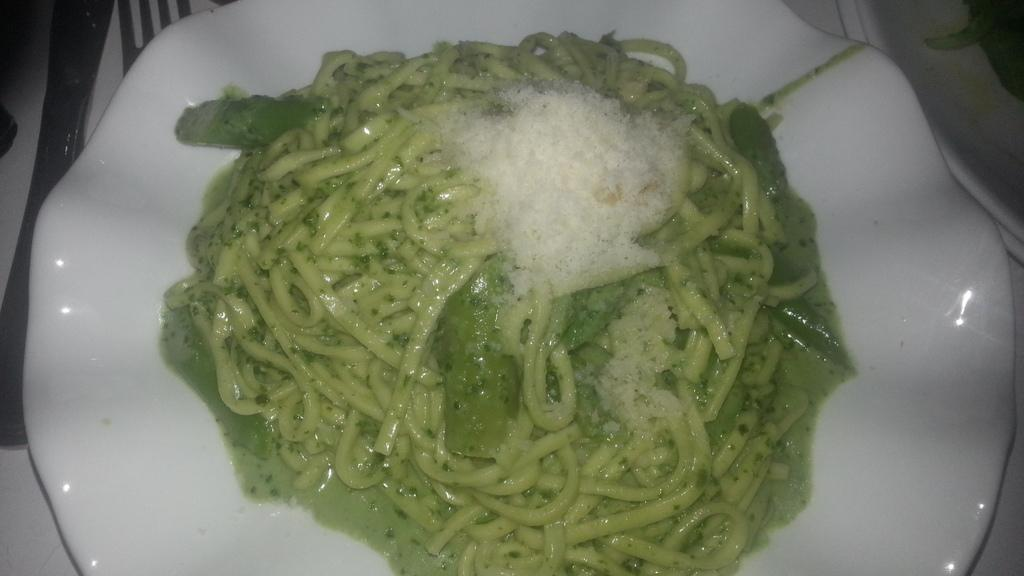What is the main subject of the image? There is a food item in the image. How is the food item presented in the image? The food item is on a plate. Where is the plate with the food item located? The plate is on a table. What type of polish is being applied to the lettuce in the image? There is no lettuce or polish present in the image. What religious symbol can be seen in the image? There is no religious symbol present in the image. 